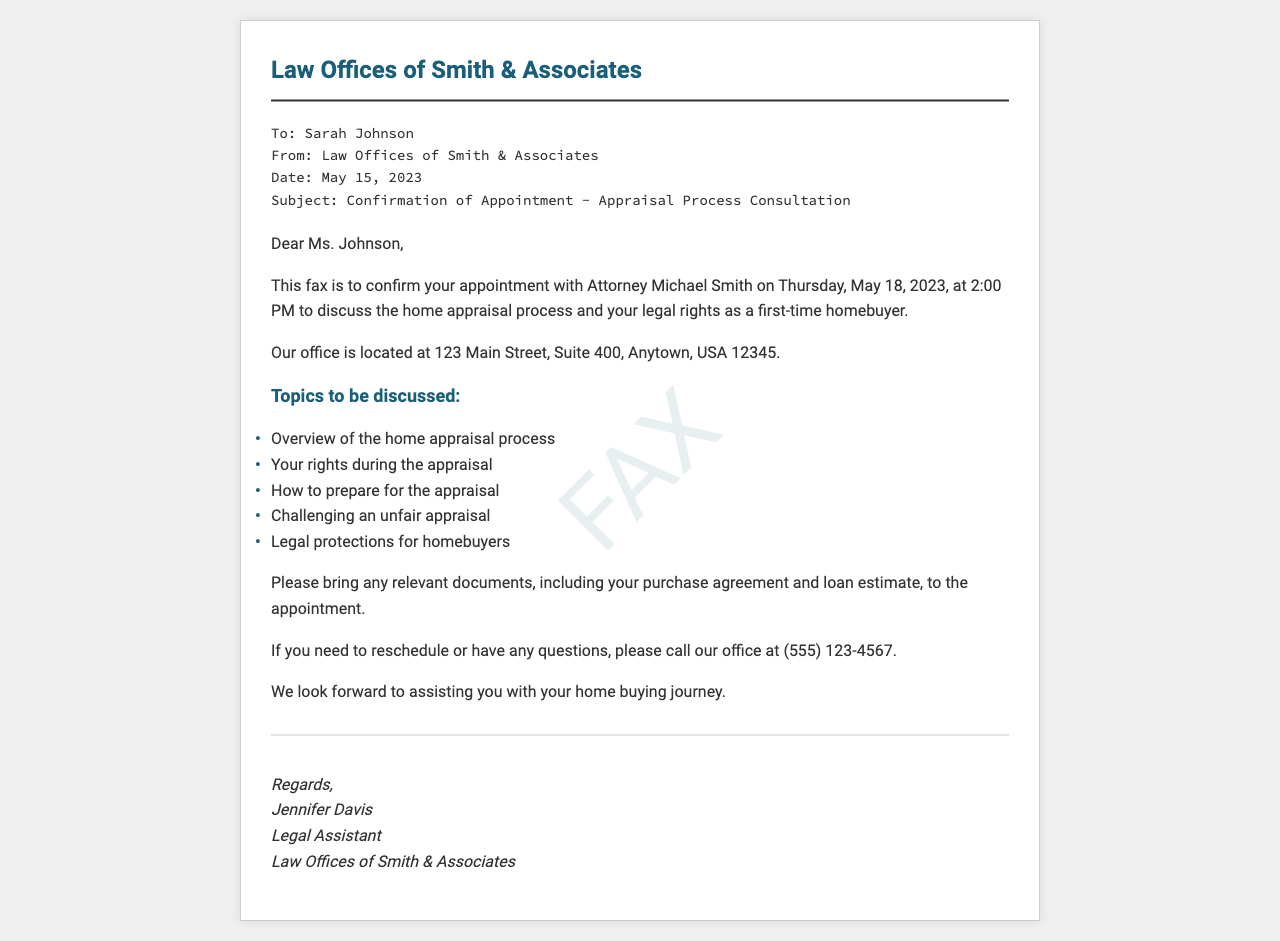what is the name of the law office? The fax confirms an appointment with the Law Offices of Smith & Associates, which is mentioned in the header.
Answer: Law Offices of Smith & Associates who is the attorney you will meet? The document states that Attorney Michael Smith is the one you will meet for your appointment.
Answer: Michael Smith what date is the appointment scheduled for? The appointment date is mentioned clearly in the body of the fax.
Answer: May 18, 2023 what time is the appointment? The specific time for the appointment is listed in the fax.
Answer: 2:00 PM where is the office located? The fax includes the address of the law office where the appointment will take place.
Answer: 123 Main Street, Suite 400, Anytown, USA 12345 what is one of the topics to be discussed? The document lists several topics, and one can be selected as an example from the list provided.
Answer: Overview of the home appraisal process what should you bring to the appointment? It is stated in the document that certain documents should be brought to the appointment.
Answer: Any relevant documents what should you do if you need to reschedule? The document provides a way to address rescheduling issues, which is through a phone call.
Answer: Call our office who signed the fax? The footer of the fax provides the signatory's name and title at the law firm.
Answer: Jennifer Davis 